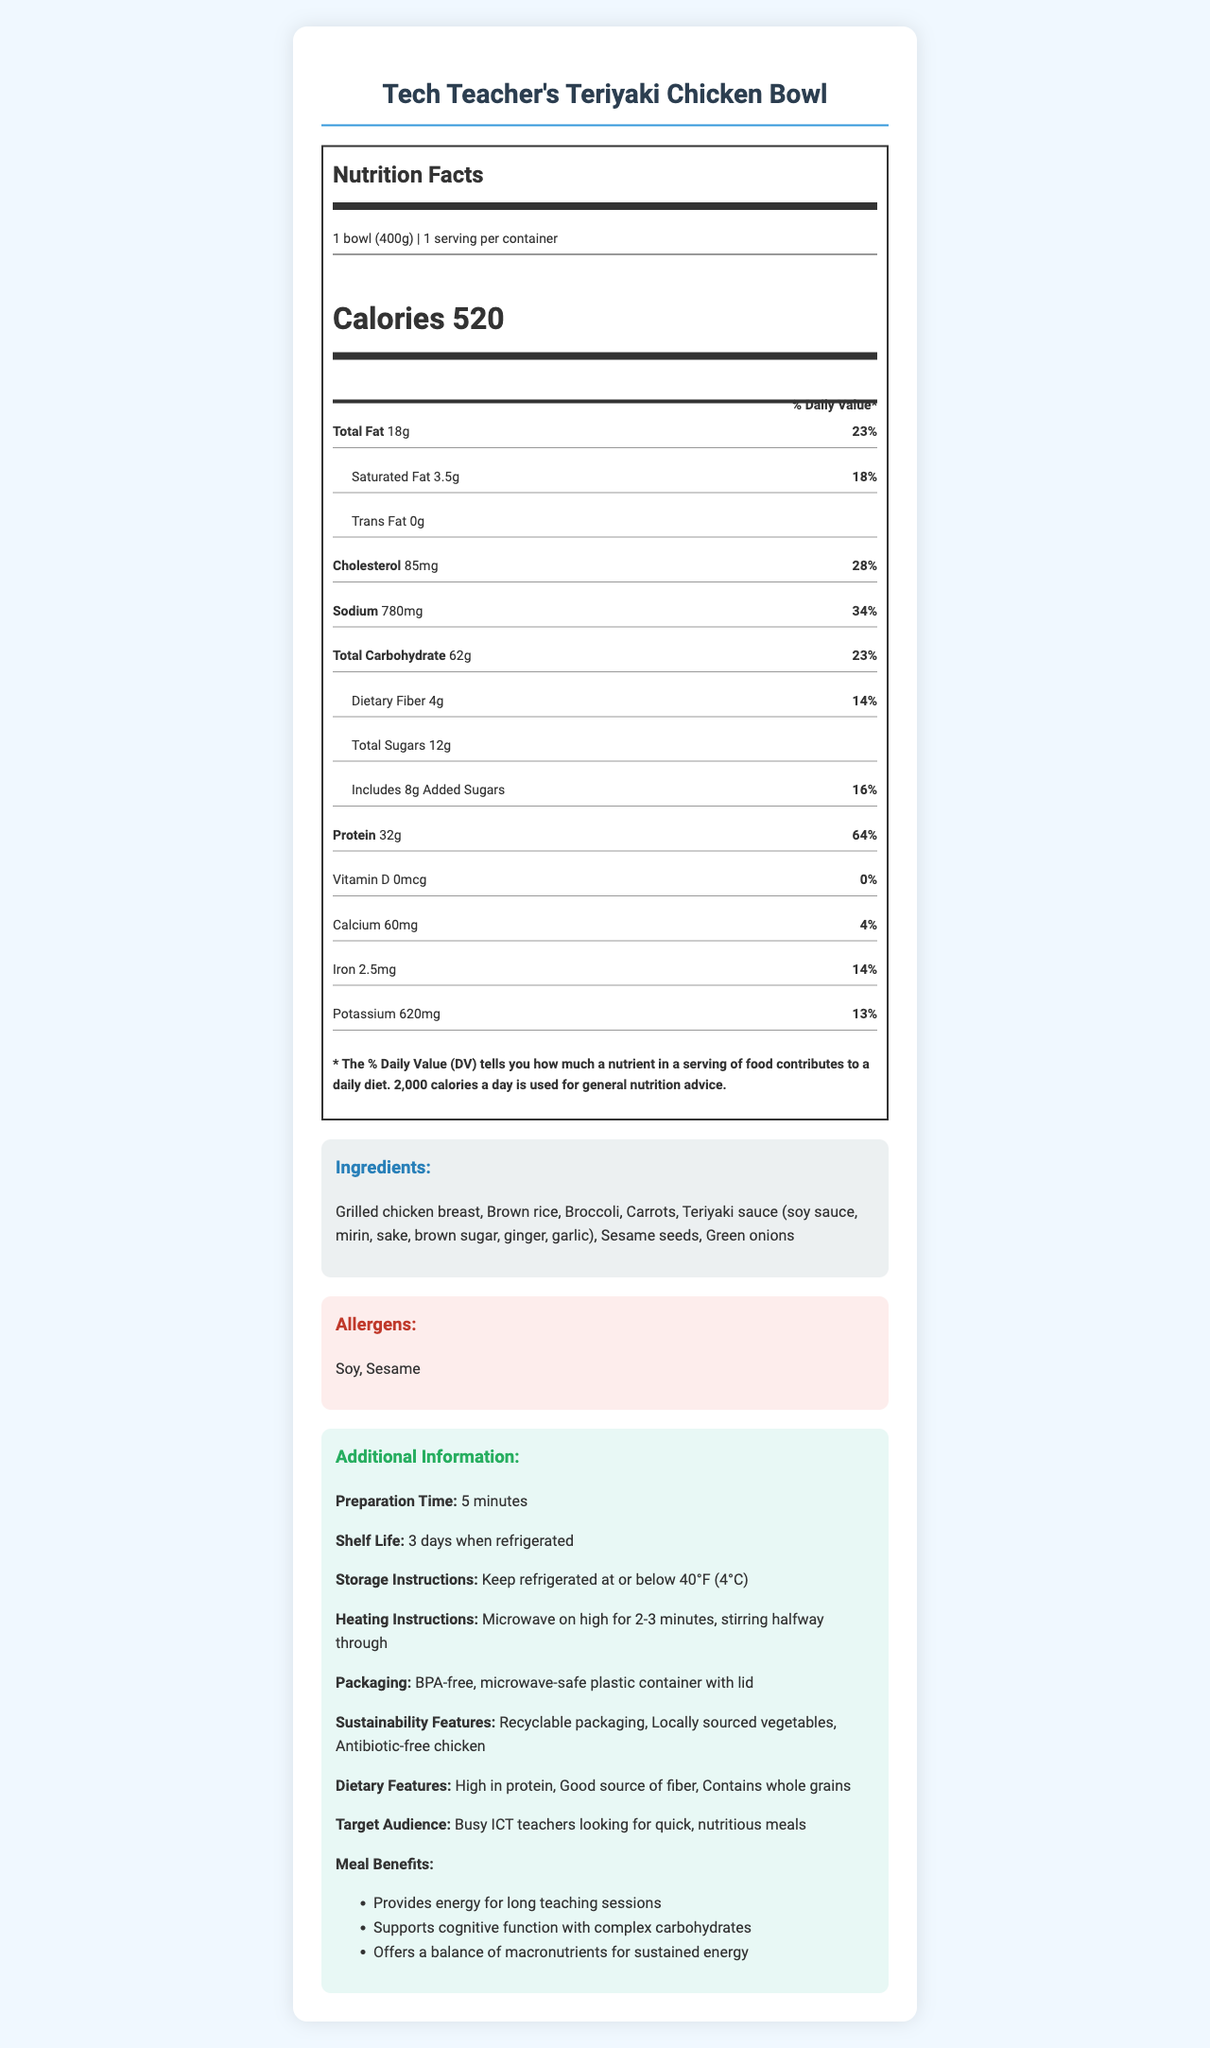what is the serving size of Tech Teacher's Teriyaki Chicken Bowl? The document states that the serving size is 1 bowl, which equates to 400 grams.
Answer: 1 bowl (400g) how many calories are in one serving of this meal kit? According to the nutrition label, each serving of the Tech Teacher's Teriyaki Chicken Bowl contains 520 calories.
Answer: 520 how many grams of protein does this meal provide? The nutrition label indicates that one serving contains 32 grams of protein.
Answer: 32g which allergens are present in this meal? The allergens section lists soy and sesame as ingredients that may cause allergic reactions.
Answer: Soy, Sesame what is the shelf life of this meal kit when refrigerated? The additional information section specifies that the meal kit has a shelf life of 3 days when refrigerated.
Answer: 3 days how much saturated fat is in one serving of the meal? The nutrition label shows that each serving contains 3.5 grams of saturated fat.
Answer: 3.5g what are the heating instructions for this meal kit? The document provides instructions to microwave the meal on high for 2-3 minutes and stir halfway through the heating process.
Answer: Microwave on high for 2-3 minutes, stirring halfway through how many milligrams of sodium does one serving contain? The nutrition label lists that one serving contains 780 milligrams of sodium.
Answer: 780mg which of the following is not a sustainability feature of the meal kit? A. Recyclable packaging B. Organic vegetables C. Locally sourced vegetables D. Antibiotic-free chicken The document lists recyclable packaging, locally sourced vegetables, and antibiotic-free chicken as sustainability features but does not mention organic vegetables.
Answer: B. Organic vegetables what percentage of the daily value for dietary fiber does this meal provide? The nutrition label indicates that the meal provides 14% of the daily value for dietary fiber.
Answer: 14% does this meal kit contain added sugars? The nutrition label clearly states that the meal contains 8 grams of added sugars.
Answer: Yes which of the following ingredients is not listed in the meal kit? A. Grilled chicken breast B. Bell peppers C. Brown rice D. Teriyaki sauce The ingredients list includes grilled chicken breast, brown rice, and teriyaki sauce, but not bell peppers.
Answer: B. Bell peppers summarize the main idea of the document The document serves as a comprehensive guide to the Tech Teacher's Teriyaki Chicken Bowl, covering everything from nutritional content and ingredient list to preparation time and storage instructions. The meal is targeted at busy ICT teachers and underscores its convenience and balanced nutrition.
Answer: The document provides detailed nutritional information, ingredients, allergens, preparation and storage instructions, and features of Tech Teacher's Teriyaki Chicken Bowl, a quick and nutritious meal kit designed for busy ICT teachers. It highlights the convenience, health benefits, and sustainability features of the meal. what is the price of this meal kit? The document does not provide any information regarding the price of the meal kit.
Answer: Not enough information 